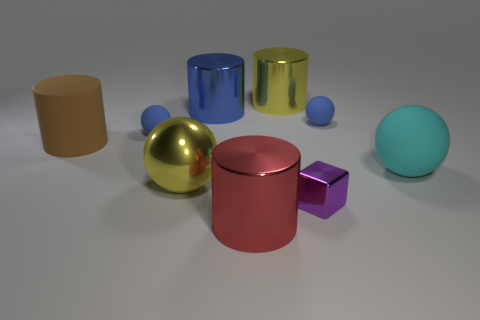Subtract all shiny balls. How many balls are left? 3 Subtract 1 spheres. How many spheres are left? 3 Subtract all gray cylinders. Subtract all green blocks. How many cylinders are left? 4 Add 1 small blue rubber balls. How many objects exist? 10 Subtract all blocks. How many objects are left? 8 Subtract all big yellow things. Subtract all big blue objects. How many objects are left? 6 Add 6 big brown things. How many big brown things are left? 7 Add 8 small yellow metal cylinders. How many small yellow metal cylinders exist? 8 Subtract 0 yellow blocks. How many objects are left? 9 